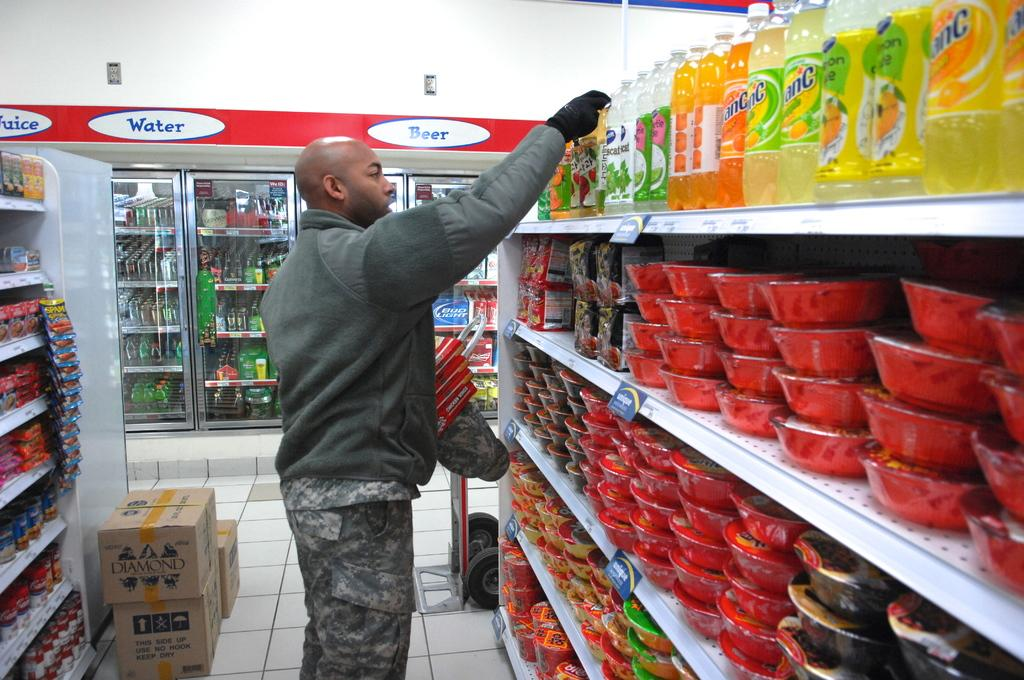<image>
Offer a succinct explanation of the picture presented. A man shopping in front of a cooler that says beer on it. 